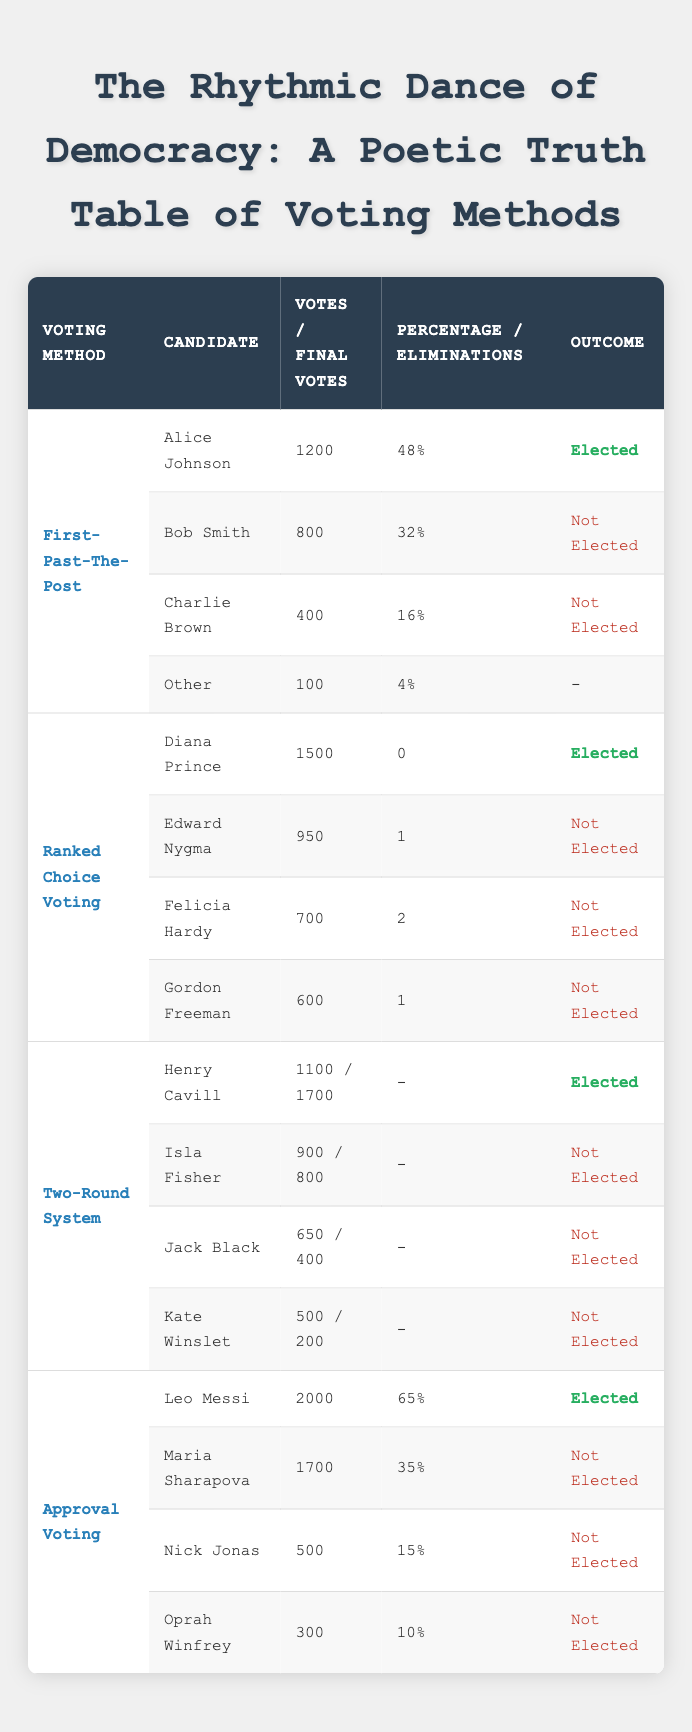What is the total number of votes received by Alice Johnson? Alice Johnson received 1200 votes, which is directly stated in the First-Past-The-Post method section of the table.
Answer: 1200 How many candidates were elected in the Ranked Choice Voting method? In the Ranked Choice Voting method, only Diana Prince was elected, as she is the only candidate marked as "Elected" in that section.
Answer: 1 What is the percentage of approved votes for Leo Messi? The table shows that Leo Messi received 2000 approved votes, with a percentage of 65%, indicated in the Approval Voting section.
Answer: 65 Which candidate had the second highest number of votes in the Two-Round System? In the Two-Round System, Henry Cavill received the highest with 1700 votes, and Isla Fisher received the second highest with 800 votes in Round 2 (900 in Round 1, but we consider Final votes), making her the second highest overall.
Answer: Isla Fisher Did any candidates in the First-Past-The-Post method receive more votes than Alice Johnson? No, Alice Johnson received the most votes (1200) in the First-Past-The-Post method, as the other candidates (Bob Smith and Charlie Brown) received fewer votes (800 and 400, respectively).
Answer: No What is the average number of final votes received by the candidates in Ranked Choice Voting? The final votes for the candidates in Ranked Choice Voting are 1500, 950, 700, and 600. Sum them up (1500 + 950 + 700 + 600 = 3750) and divide by the number of candidates (4) to get the average: 3750 / 4 = 937.5.
Answer: 937.5 Which voting method resulted in the highest percentage of votes for an elected candidate? In the Approval Voting method, Leo Messi received 2000 votes at 65%, which is higher than any percentage in the other methods, where the highest elected candidates had lower percentages.
Answer: Approval Voting What was the total number of votes for all candidates in the Approval Voting method? For Approval Voting, the total votes can be calculated by summing the approved votes of all candidates: 2000 (Leo Messi) + 1700 (Maria Sharapova) + 500 (Nick Jonas) + 300 (Oprah Winfrey) = 4500.
Answer: 4500 